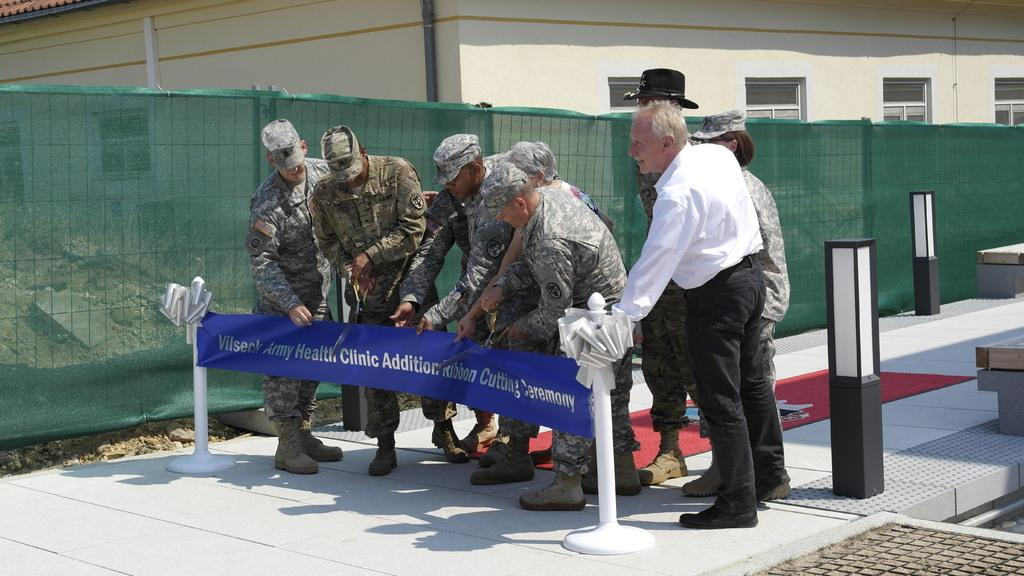What can be seen in the image regarding people? There are men standing in the image. What objects are present in the image that might be related to traffic or crowd control? There are barrier poles in the image. What type of seating is available in the image? There are benches in the image. What type of structures can be seen in the background of the image? There are buildings in the image. What can be observed about the ground in the image? There are stones on the ground in the image. What type of chess pieces are visible on the benches in the image? There are no chess pieces visible on the benches in the image. What decision did the men make while standing in the image? The image does not provide information about any decisions made by the men. 